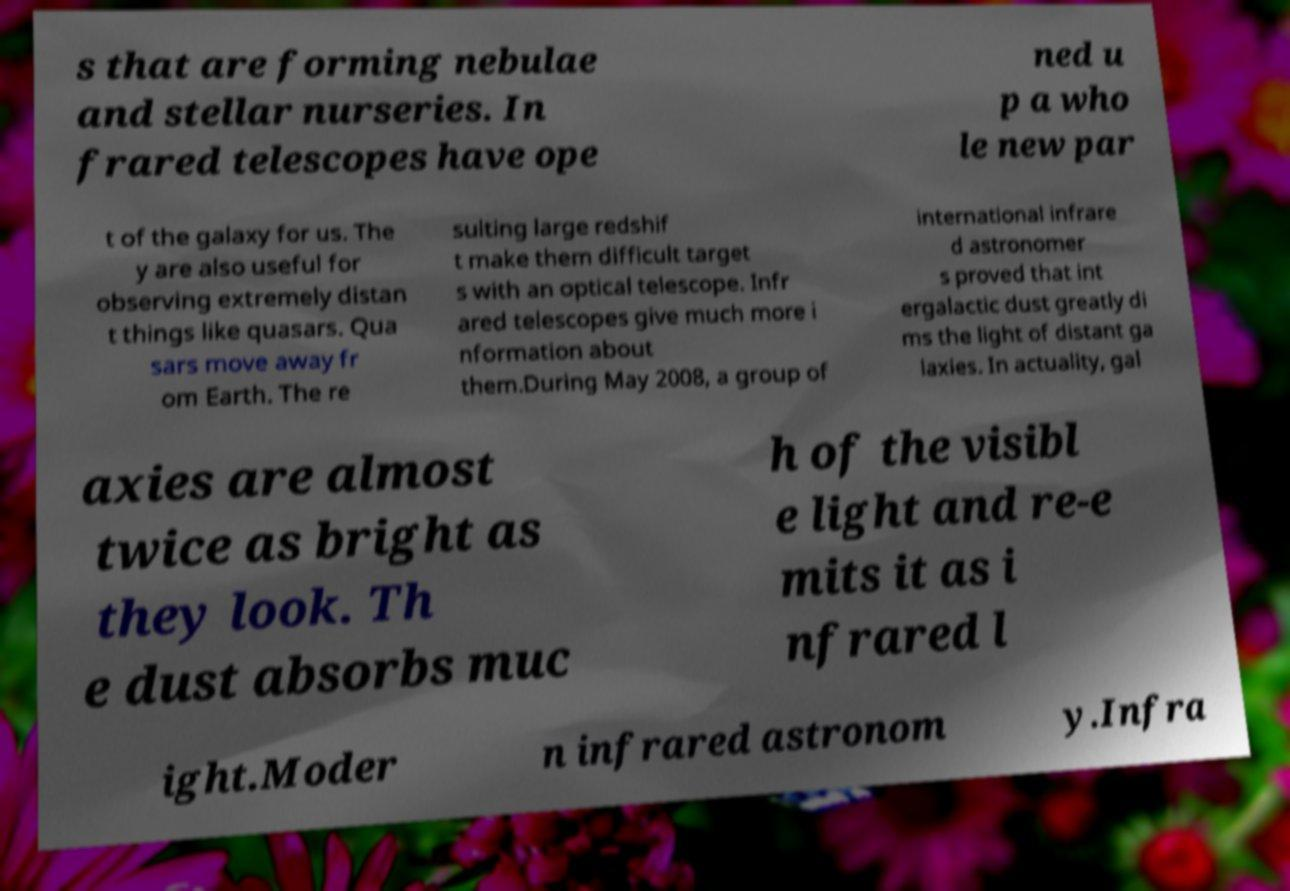Could you extract and type out the text from this image? s that are forming nebulae and stellar nurseries. In frared telescopes have ope ned u p a who le new par t of the galaxy for us. The y are also useful for observing extremely distan t things like quasars. Qua sars move away fr om Earth. The re sulting large redshif t make them difficult target s with an optical telescope. Infr ared telescopes give much more i nformation about them.During May 2008, a group of international infrare d astronomer s proved that int ergalactic dust greatly di ms the light of distant ga laxies. In actuality, gal axies are almost twice as bright as they look. Th e dust absorbs muc h of the visibl e light and re-e mits it as i nfrared l ight.Moder n infrared astronom y.Infra 